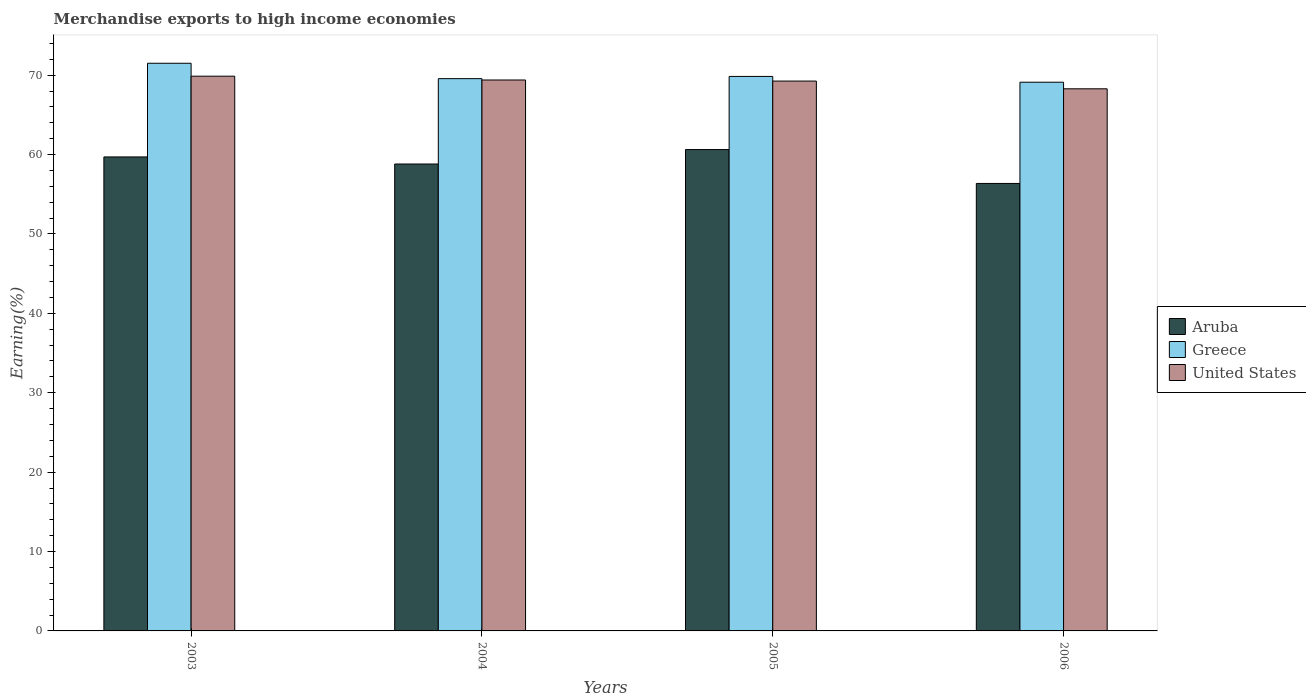How many different coloured bars are there?
Offer a very short reply. 3. How many groups of bars are there?
Give a very brief answer. 4. Are the number of bars per tick equal to the number of legend labels?
Your answer should be compact. Yes. What is the label of the 2nd group of bars from the left?
Keep it short and to the point. 2004. In how many cases, is the number of bars for a given year not equal to the number of legend labels?
Provide a succinct answer. 0. What is the percentage of amount earned from merchandise exports in United States in 2005?
Your response must be concise. 69.26. Across all years, what is the maximum percentage of amount earned from merchandise exports in United States?
Provide a short and direct response. 69.87. Across all years, what is the minimum percentage of amount earned from merchandise exports in Aruba?
Make the answer very short. 56.36. In which year was the percentage of amount earned from merchandise exports in United States minimum?
Provide a succinct answer. 2006. What is the total percentage of amount earned from merchandise exports in Greece in the graph?
Provide a succinct answer. 280.02. What is the difference between the percentage of amount earned from merchandise exports in United States in 2003 and that in 2006?
Provide a succinct answer. 1.59. What is the difference between the percentage of amount earned from merchandise exports in Greece in 2005 and the percentage of amount earned from merchandise exports in Aruba in 2003?
Make the answer very short. 10.14. What is the average percentage of amount earned from merchandise exports in Greece per year?
Provide a succinct answer. 70. In the year 2004, what is the difference between the percentage of amount earned from merchandise exports in Aruba and percentage of amount earned from merchandise exports in Greece?
Offer a terse response. -10.75. In how many years, is the percentage of amount earned from merchandise exports in United States greater than 50 %?
Make the answer very short. 4. What is the ratio of the percentage of amount earned from merchandise exports in United States in 2004 to that in 2005?
Ensure brevity in your answer.  1. Is the difference between the percentage of amount earned from merchandise exports in Aruba in 2003 and 2004 greater than the difference between the percentage of amount earned from merchandise exports in Greece in 2003 and 2004?
Provide a short and direct response. No. What is the difference between the highest and the second highest percentage of amount earned from merchandise exports in Greece?
Offer a terse response. 1.66. What is the difference between the highest and the lowest percentage of amount earned from merchandise exports in Aruba?
Your answer should be very brief. 4.27. In how many years, is the percentage of amount earned from merchandise exports in United States greater than the average percentage of amount earned from merchandise exports in United States taken over all years?
Keep it short and to the point. 3. What does the 3rd bar from the left in 2006 represents?
Give a very brief answer. United States. What does the 3rd bar from the right in 2003 represents?
Your answer should be very brief. Aruba. Is it the case that in every year, the sum of the percentage of amount earned from merchandise exports in United States and percentage of amount earned from merchandise exports in Greece is greater than the percentage of amount earned from merchandise exports in Aruba?
Your response must be concise. Yes. What is the difference between two consecutive major ticks on the Y-axis?
Give a very brief answer. 10. Are the values on the major ticks of Y-axis written in scientific E-notation?
Offer a very short reply. No. How many legend labels are there?
Keep it short and to the point. 3. What is the title of the graph?
Offer a terse response. Merchandise exports to high income economies. What is the label or title of the X-axis?
Offer a terse response. Years. What is the label or title of the Y-axis?
Offer a very short reply. Earning(%). What is the Earning(%) in Aruba in 2003?
Your response must be concise. 59.7. What is the Earning(%) of Greece in 2003?
Provide a short and direct response. 71.5. What is the Earning(%) in United States in 2003?
Your answer should be compact. 69.87. What is the Earning(%) of Aruba in 2004?
Make the answer very short. 58.81. What is the Earning(%) of Greece in 2004?
Your answer should be compact. 69.56. What is the Earning(%) in United States in 2004?
Make the answer very short. 69.39. What is the Earning(%) in Aruba in 2005?
Your answer should be very brief. 60.63. What is the Earning(%) of Greece in 2005?
Offer a terse response. 69.84. What is the Earning(%) of United States in 2005?
Keep it short and to the point. 69.26. What is the Earning(%) of Aruba in 2006?
Your response must be concise. 56.36. What is the Earning(%) in Greece in 2006?
Give a very brief answer. 69.11. What is the Earning(%) in United States in 2006?
Offer a very short reply. 68.28. Across all years, what is the maximum Earning(%) in Aruba?
Make the answer very short. 60.63. Across all years, what is the maximum Earning(%) of Greece?
Make the answer very short. 71.5. Across all years, what is the maximum Earning(%) of United States?
Keep it short and to the point. 69.87. Across all years, what is the minimum Earning(%) in Aruba?
Ensure brevity in your answer.  56.36. Across all years, what is the minimum Earning(%) in Greece?
Ensure brevity in your answer.  69.11. Across all years, what is the minimum Earning(%) in United States?
Keep it short and to the point. 68.28. What is the total Earning(%) of Aruba in the graph?
Offer a very short reply. 235.51. What is the total Earning(%) in Greece in the graph?
Offer a terse response. 280.02. What is the total Earning(%) of United States in the graph?
Your answer should be compact. 276.81. What is the difference between the Earning(%) in Aruba in 2003 and that in 2004?
Ensure brevity in your answer.  0.89. What is the difference between the Earning(%) of Greece in 2003 and that in 2004?
Provide a short and direct response. 1.94. What is the difference between the Earning(%) of United States in 2003 and that in 2004?
Provide a succinct answer. 0.48. What is the difference between the Earning(%) in Aruba in 2003 and that in 2005?
Your response must be concise. -0.93. What is the difference between the Earning(%) in Greece in 2003 and that in 2005?
Provide a short and direct response. 1.66. What is the difference between the Earning(%) of United States in 2003 and that in 2005?
Provide a short and direct response. 0.62. What is the difference between the Earning(%) of Aruba in 2003 and that in 2006?
Your answer should be very brief. 3.34. What is the difference between the Earning(%) of Greece in 2003 and that in 2006?
Provide a short and direct response. 2.39. What is the difference between the Earning(%) of United States in 2003 and that in 2006?
Keep it short and to the point. 1.59. What is the difference between the Earning(%) of Aruba in 2004 and that in 2005?
Make the answer very short. -1.82. What is the difference between the Earning(%) of Greece in 2004 and that in 2005?
Your response must be concise. -0.28. What is the difference between the Earning(%) of United States in 2004 and that in 2005?
Provide a short and direct response. 0.14. What is the difference between the Earning(%) in Aruba in 2004 and that in 2006?
Give a very brief answer. 2.45. What is the difference between the Earning(%) of Greece in 2004 and that in 2006?
Keep it short and to the point. 0.45. What is the difference between the Earning(%) of United States in 2004 and that in 2006?
Offer a terse response. 1.11. What is the difference between the Earning(%) of Aruba in 2005 and that in 2006?
Your answer should be very brief. 4.27. What is the difference between the Earning(%) in Greece in 2005 and that in 2006?
Provide a short and direct response. 0.73. What is the difference between the Earning(%) of United States in 2005 and that in 2006?
Provide a succinct answer. 0.97. What is the difference between the Earning(%) in Aruba in 2003 and the Earning(%) in Greece in 2004?
Ensure brevity in your answer.  -9.86. What is the difference between the Earning(%) of Aruba in 2003 and the Earning(%) of United States in 2004?
Give a very brief answer. -9.69. What is the difference between the Earning(%) in Greece in 2003 and the Earning(%) in United States in 2004?
Give a very brief answer. 2.11. What is the difference between the Earning(%) in Aruba in 2003 and the Earning(%) in Greece in 2005?
Offer a very short reply. -10.14. What is the difference between the Earning(%) in Aruba in 2003 and the Earning(%) in United States in 2005?
Ensure brevity in your answer.  -9.55. What is the difference between the Earning(%) of Greece in 2003 and the Earning(%) of United States in 2005?
Provide a short and direct response. 2.24. What is the difference between the Earning(%) in Aruba in 2003 and the Earning(%) in Greece in 2006?
Your answer should be compact. -9.41. What is the difference between the Earning(%) in Aruba in 2003 and the Earning(%) in United States in 2006?
Provide a succinct answer. -8.58. What is the difference between the Earning(%) in Greece in 2003 and the Earning(%) in United States in 2006?
Give a very brief answer. 3.22. What is the difference between the Earning(%) in Aruba in 2004 and the Earning(%) in Greece in 2005?
Your answer should be very brief. -11.03. What is the difference between the Earning(%) of Aruba in 2004 and the Earning(%) of United States in 2005?
Your response must be concise. -10.45. What is the difference between the Earning(%) in Greece in 2004 and the Earning(%) in United States in 2005?
Your answer should be very brief. 0.31. What is the difference between the Earning(%) of Aruba in 2004 and the Earning(%) of Greece in 2006?
Ensure brevity in your answer.  -10.3. What is the difference between the Earning(%) of Aruba in 2004 and the Earning(%) of United States in 2006?
Provide a short and direct response. -9.47. What is the difference between the Earning(%) in Greece in 2004 and the Earning(%) in United States in 2006?
Your response must be concise. 1.28. What is the difference between the Earning(%) of Aruba in 2005 and the Earning(%) of Greece in 2006?
Provide a succinct answer. -8.48. What is the difference between the Earning(%) of Aruba in 2005 and the Earning(%) of United States in 2006?
Offer a terse response. -7.65. What is the difference between the Earning(%) in Greece in 2005 and the Earning(%) in United States in 2006?
Provide a succinct answer. 1.56. What is the average Earning(%) of Aruba per year?
Make the answer very short. 58.88. What is the average Earning(%) of Greece per year?
Your response must be concise. 70. What is the average Earning(%) of United States per year?
Give a very brief answer. 69.2. In the year 2003, what is the difference between the Earning(%) of Aruba and Earning(%) of Greece?
Your answer should be very brief. -11.8. In the year 2003, what is the difference between the Earning(%) of Aruba and Earning(%) of United States?
Provide a short and direct response. -10.17. In the year 2003, what is the difference between the Earning(%) in Greece and Earning(%) in United States?
Your answer should be compact. 1.63. In the year 2004, what is the difference between the Earning(%) of Aruba and Earning(%) of Greece?
Make the answer very short. -10.75. In the year 2004, what is the difference between the Earning(%) in Aruba and Earning(%) in United States?
Offer a very short reply. -10.58. In the year 2004, what is the difference between the Earning(%) of Greece and Earning(%) of United States?
Make the answer very short. 0.17. In the year 2005, what is the difference between the Earning(%) in Aruba and Earning(%) in Greece?
Offer a terse response. -9.21. In the year 2005, what is the difference between the Earning(%) in Aruba and Earning(%) in United States?
Your response must be concise. -8.63. In the year 2005, what is the difference between the Earning(%) of Greece and Earning(%) of United States?
Provide a succinct answer. 0.58. In the year 2006, what is the difference between the Earning(%) of Aruba and Earning(%) of Greece?
Provide a succinct answer. -12.75. In the year 2006, what is the difference between the Earning(%) of Aruba and Earning(%) of United States?
Your answer should be compact. -11.92. In the year 2006, what is the difference between the Earning(%) of Greece and Earning(%) of United States?
Offer a terse response. 0.83. What is the ratio of the Earning(%) of Aruba in 2003 to that in 2004?
Your answer should be compact. 1.02. What is the ratio of the Earning(%) of Greece in 2003 to that in 2004?
Provide a succinct answer. 1.03. What is the ratio of the Earning(%) of Aruba in 2003 to that in 2005?
Keep it short and to the point. 0.98. What is the ratio of the Earning(%) of Greece in 2003 to that in 2005?
Your response must be concise. 1.02. What is the ratio of the Earning(%) of United States in 2003 to that in 2005?
Provide a succinct answer. 1.01. What is the ratio of the Earning(%) of Aruba in 2003 to that in 2006?
Your answer should be compact. 1.06. What is the ratio of the Earning(%) of Greece in 2003 to that in 2006?
Provide a succinct answer. 1.03. What is the ratio of the Earning(%) in United States in 2003 to that in 2006?
Offer a terse response. 1.02. What is the ratio of the Earning(%) of Aruba in 2004 to that in 2005?
Ensure brevity in your answer.  0.97. What is the ratio of the Earning(%) in Greece in 2004 to that in 2005?
Offer a terse response. 1. What is the ratio of the Earning(%) in United States in 2004 to that in 2005?
Ensure brevity in your answer.  1. What is the ratio of the Earning(%) of Aruba in 2004 to that in 2006?
Provide a short and direct response. 1.04. What is the ratio of the Earning(%) of Greece in 2004 to that in 2006?
Keep it short and to the point. 1.01. What is the ratio of the Earning(%) in United States in 2004 to that in 2006?
Ensure brevity in your answer.  1.02. What is the ratio of the Earning(%) of Aruba in 2005 to that in 2006?
Your response must be concise. 1.08. What is the ratio of the Earning(%) in Greece in 2005 to that in 2006?
Keep it short and to the point. 1.01. What is the ratio of the Earning(%) in United States in 2005 to that in 2006?
Provide a short and direct response. 1.01. What is the difference between the highest and the second highest Earning(%) in Aruba?
Provide a succinct answer. 0.93. What is the difference between the highest and the second highest Earning(%) in Greece?
Make the answer very short. 1.66. What is the difference between the highest and the second highest Earning(%) of United States?
Offer a terse response. 0.48. What is the difference between the highest and the lowest Earning(%) of Aruba?
Ensure brevity in your answer.  4.27. What is the difference between the highest and the lowest Earning(%) in Greece?
Keep it short and to the point. 2.39. What is the difference between the highest and the lowest Earning(%) in United States?
Offer a terse response. 1.59. 